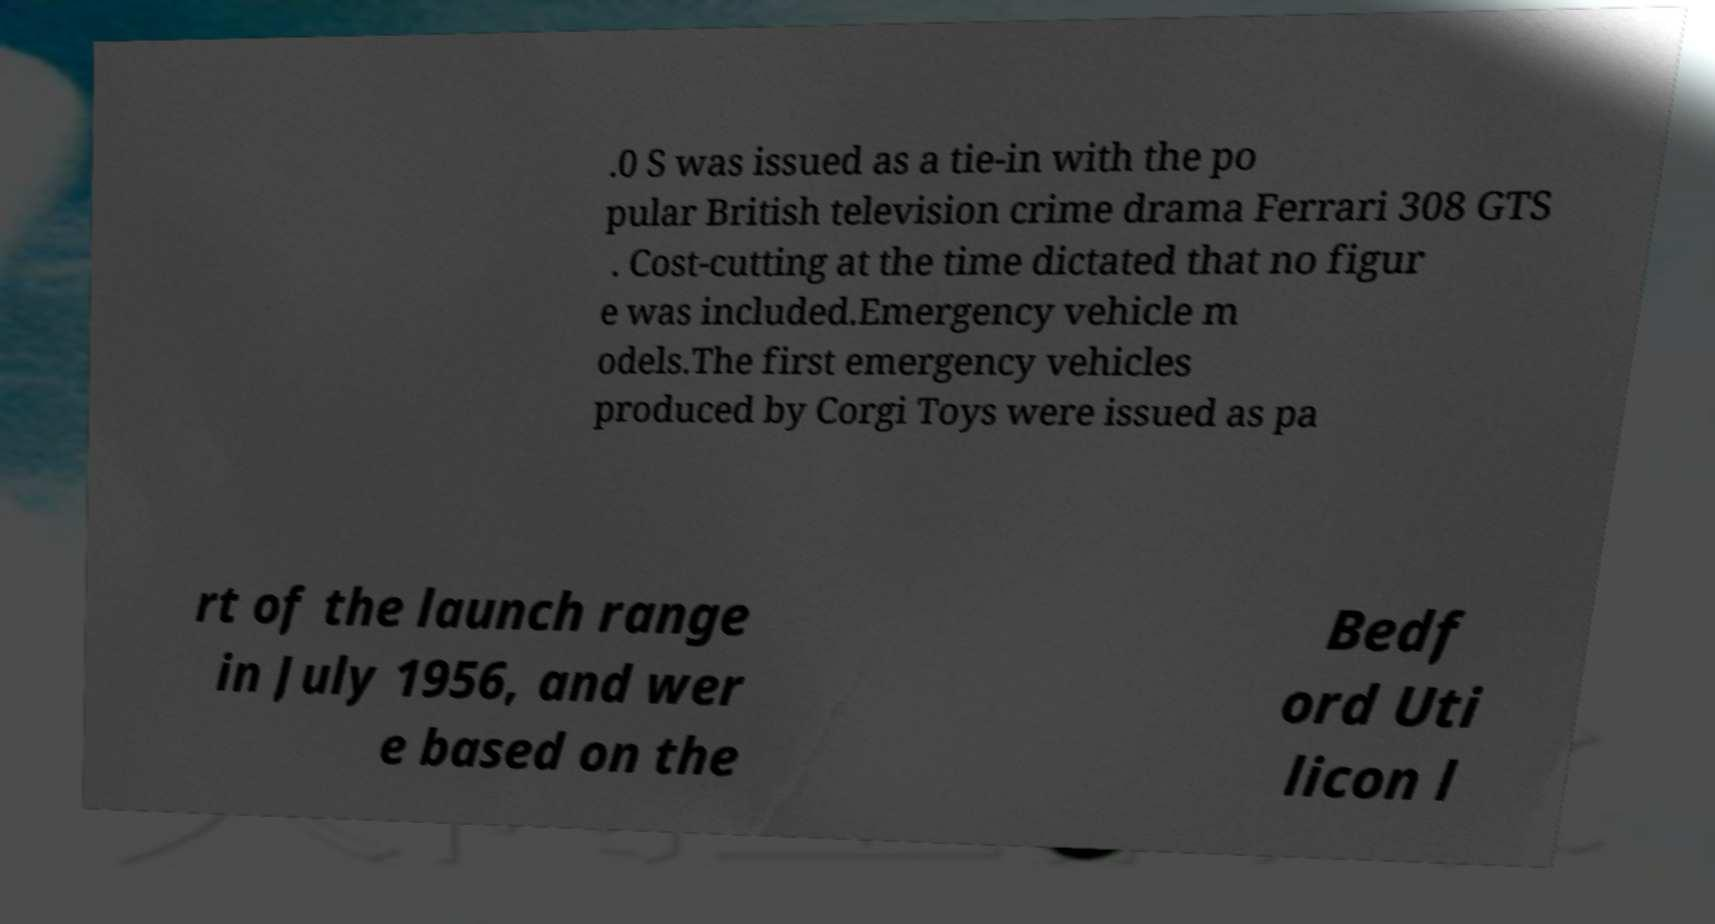Can you accurately transcribe the text from the provided image for me? .0 S was issued as a tie-in with the po pular British television crime drama Ferrari 308 GTS . Cost-cutting at the time dictated that no figur e was included.Emergency vehicle m odels.The first emergency vehicles produced by Corgi Toys were issued as pa rt of the launch range in July 1956, and wer e based on the Bedf ord Uti licon l 